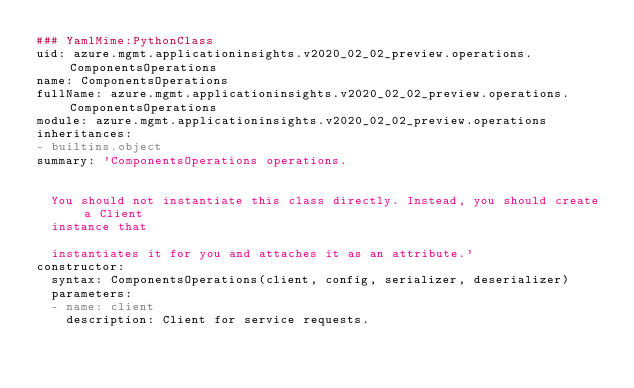<code> <loc_0><loc_0><loc_500><loc_500><_YAML_>### YamlMime:PythonClass
uid: azure.mgmt.applicationinsights.v2020_02_02_preview.operations.ComponentsOperations
name: ComponentsOperations
fullName: azure.mgmt.applicationinsights.v2020_02_02_preview.operations.ComponentsOperations
module: azure.mgmt.applicationinsights.v2020_02_02_preview.operations
inheritances:
- builtins.object
summary: 'ComponentsOperations operations.


  You should not instantiate this class directly. Instead, you should create a Client
  instance that

  instantiates it for you and attaches it as an attribute.'
constructor:
  syntax: ComponentsOperations(client, config, serializer, deserializer)
  parameters:
  - name: client
    description: Client for service requests.</code> 